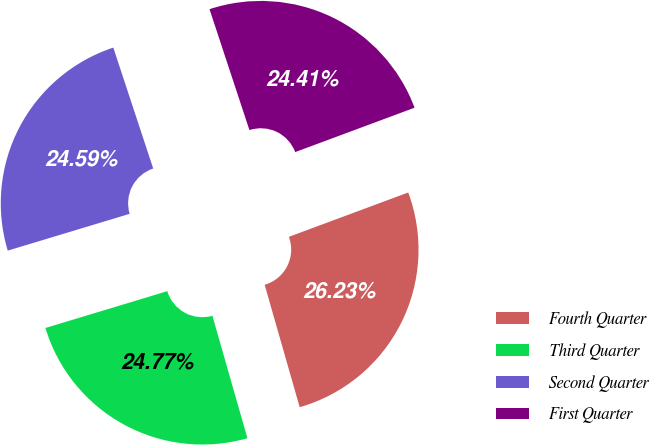Convert chart to OTSL. <chart><loc_0><loc_0><loc_500><loc_500><pie_chart><fcel>Fourth Quarter<fcel>Third Quarter<fcel>Second Quarter<fcel>First Quarter<nl><fcel>26.23%<fcel>24.77%<fcel>24.59%<fcel>24.41%<nl></chart> 